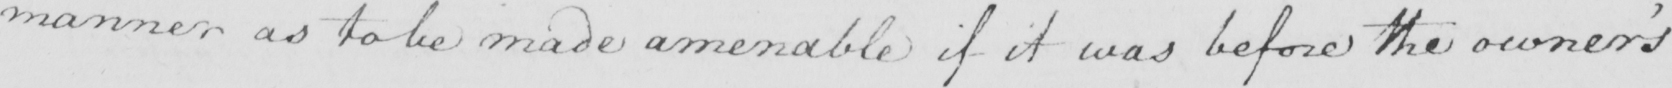Transcribe the text shown in this historical manuscript line. manner as to be made amenable if it was before the owner ' s 